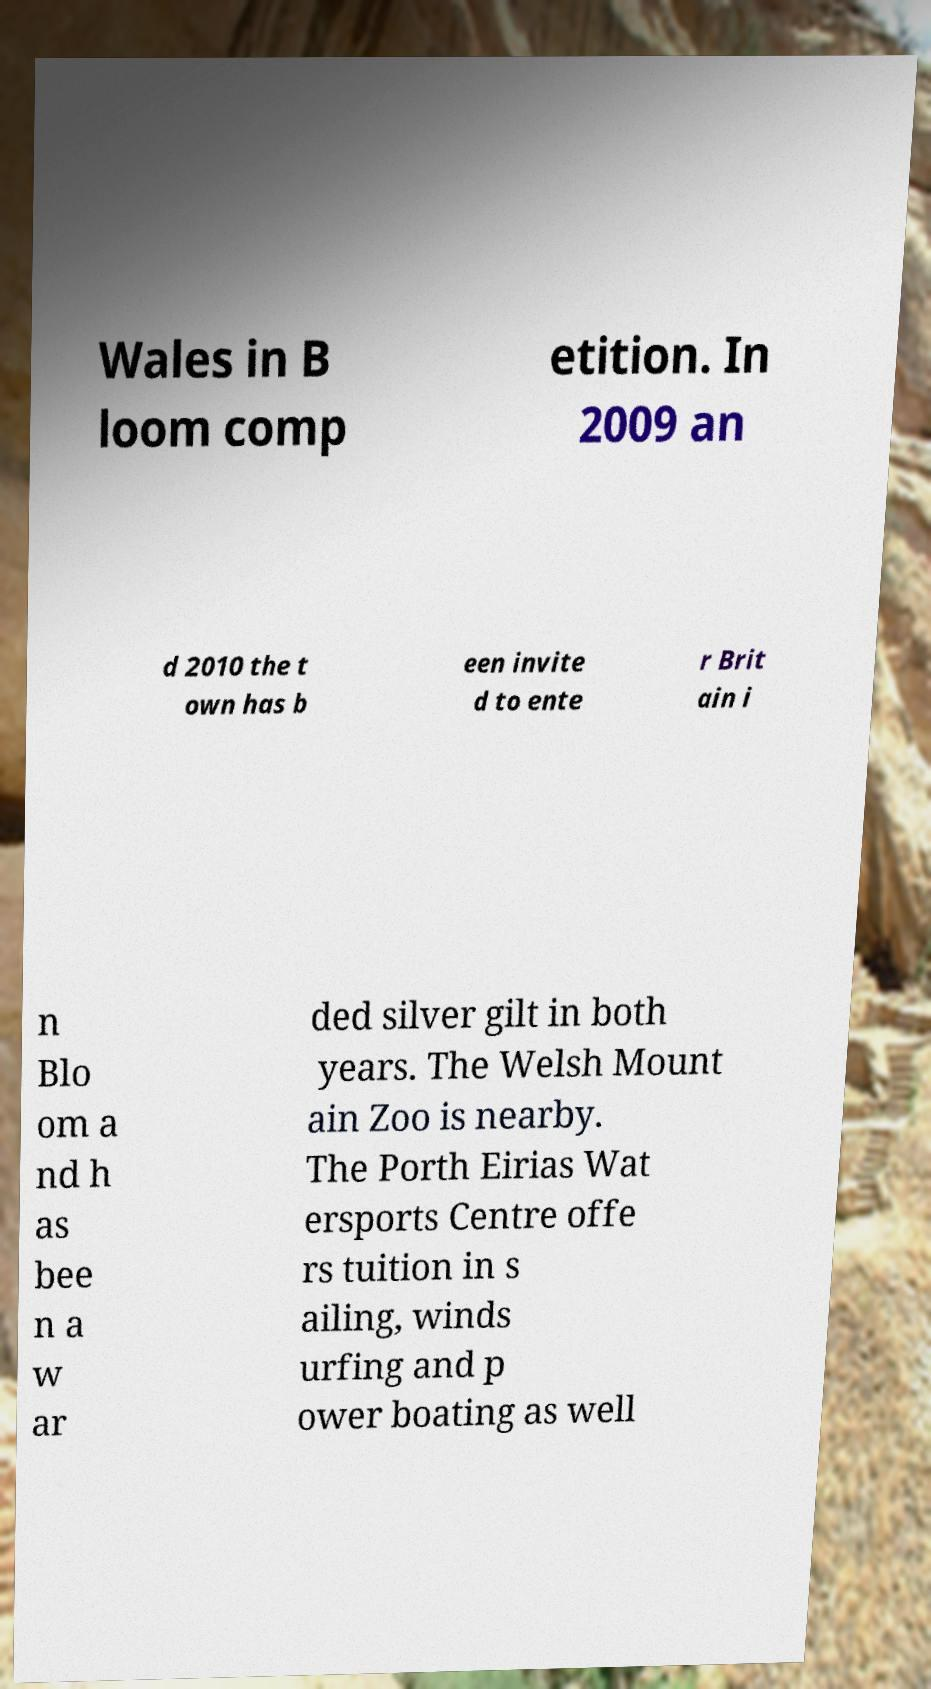Please read and relay the text visible in this image. What does it say? Wales in B loom comp etition. In 2009 an d 2010 the t own has b een invite d to ente r Brit ain i n Blo om a nd h as bee n a w ar ded silver gilt in both years. The Welsh Mount ain Zoo is nearby. The Porth Eirias Wat ersports Centre offe rs tuition in s ailing, winds urfing and p ower boating as well 